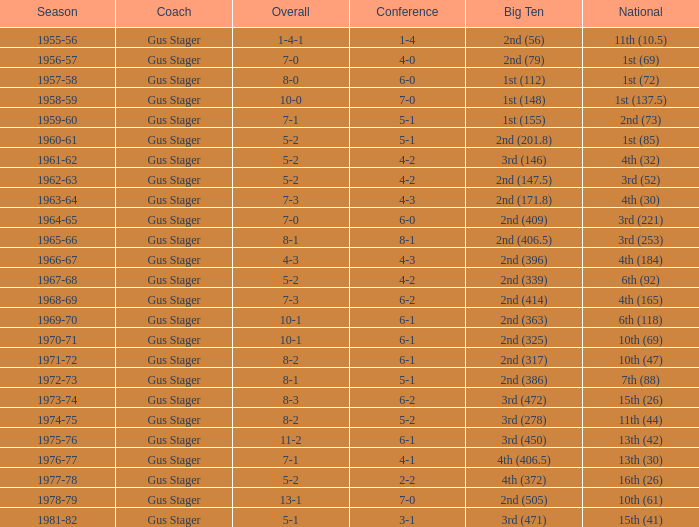Who is the big ten coach ranked 3rd (278) with an impressive record? Gus Stager. 